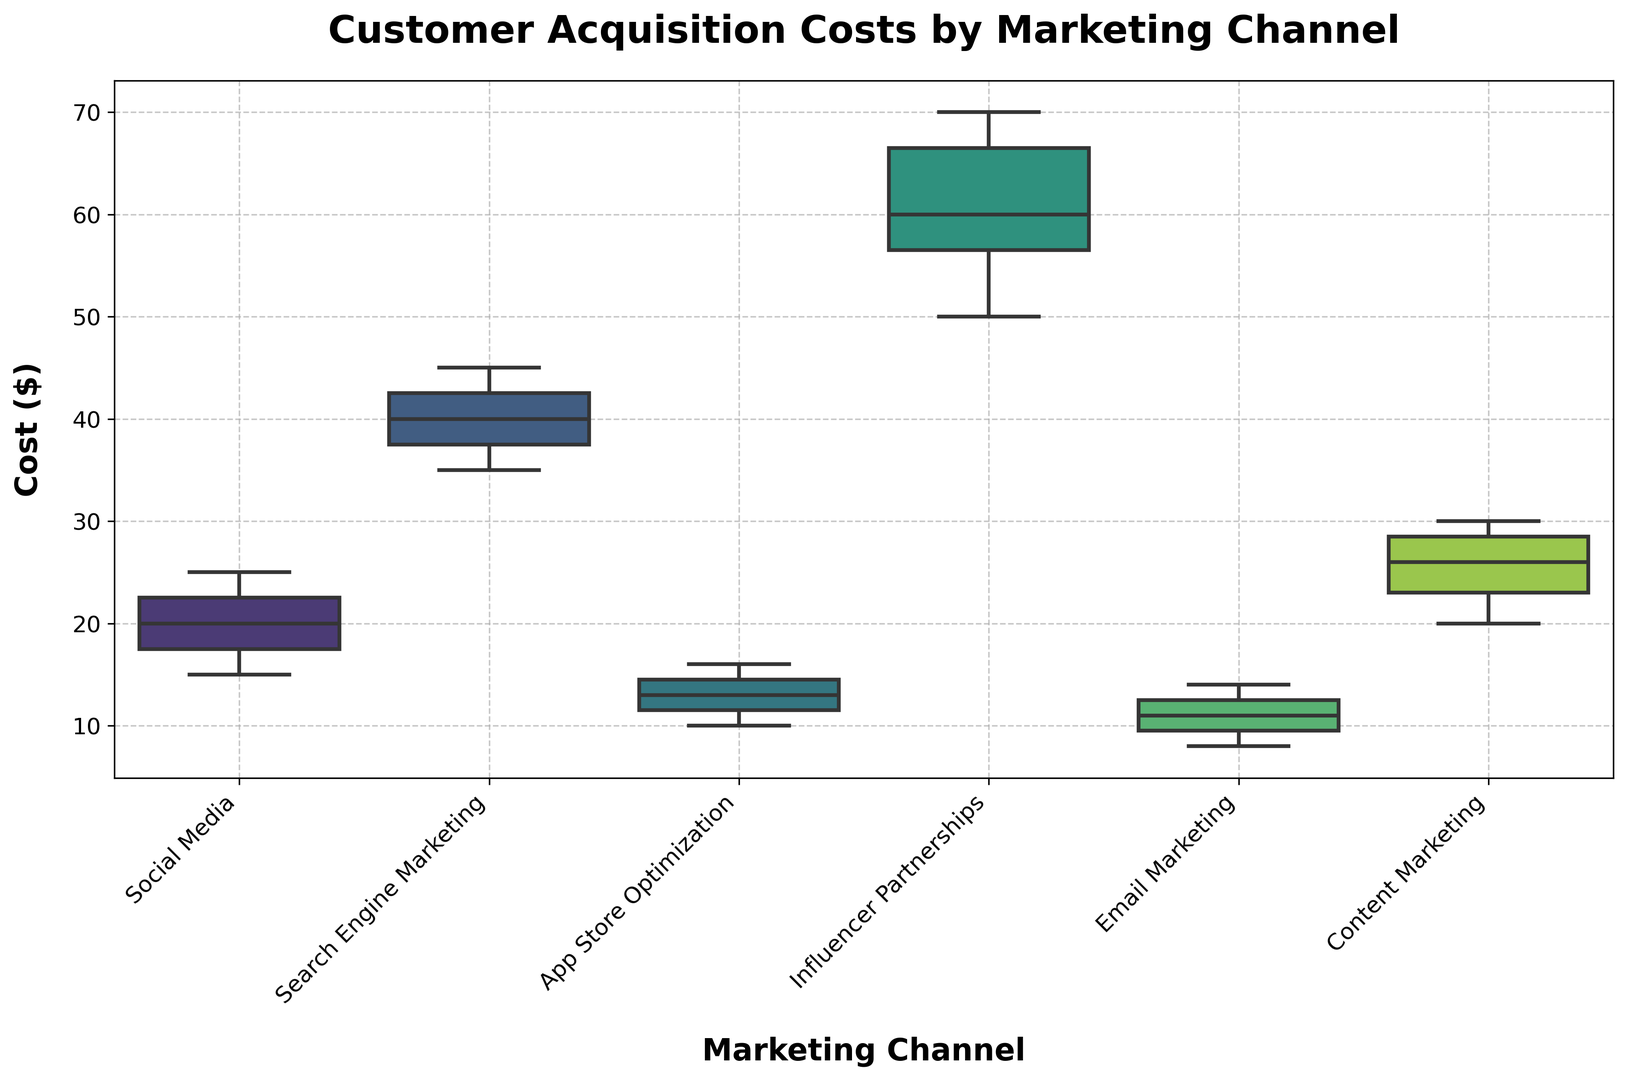Which marketing channel has the highest median customer acquisition cost? By examining the middle line (median) in each box, it's apparent that "Influencer Partnerships" has the highest median value.
Answer: Influencer Partnerships What is the interquartile range (IQR) for Search Engine Marketing? The interquartile range is calculated as the difference between the upper quartile (75th percentile) and lower quartile (25th percentile). By looking at the top and bottom of the box for "Search Engine Marketing", you can estimate these values and calculate the difference.
Answer: 8 Which marketing channel achieves the lowest customer acquisition costs? Looking at the overall distribution of the box plots, "Email Marketing" has the lowest range of customer acquisition costs.
Answer: Email Marketing Compare the range of customer acquisition costs between Social Media and Content Marketing. Which one is larger? The range is calculated by subtracting the minimum from the maximum values. By comparing the length of the whiskers and the box of each plot, Social Media has a smaller range compared to Content Marketing.
Answer: Content Marketing Which marketing channel has the largest variability in customer acquisition cost? Variability is indicated by the range and spread of the box plot, including the whiskers and any potential outliers. "Influencer Partnerships" has the largest variability based on these criteria.
Answer: Influencer Partnerships How do the median customer acquisition costs for App Store Optimization and Content Marketing compare? By comparing the middle lines in the boxes for "App Store Optimization" and "Content Marketing", the median cost for App Store Optimization is lower than that for Content Marketing.
Answer: App Store Optimization has a lower median What is the maximum customer acquisition cost for Influencer Partnerships? The top whisker or the highest point of the box plot for "Influencer Partnerships" indicates the maximum value, which is around $70.
Answer: 70 Does Social Media acquisition cost have any outliers? The presence of outliers is shown by individual points outside the whiskers. In the Social Media box plot, there are no points outside the whiskers.
Answer: No Among Email Marketing, Social Media, and App Store Optimization, which has the highest upper quartile (75th percentile)? The upper quartile is indicated by the top edge of the box. By comparing the top edges for these categories, Social Media has the highest upper quartile.
Answer: Social Media What is the range of costs for Email Marketing? The range is the difference between the maximum and minimum values, which can be found by looking at the tips of the whiskers for "Email Marketing".
Answer: 6 